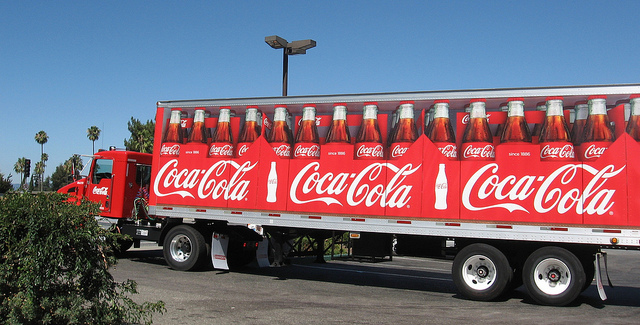Identify the text displayed in this image. CocaCola CocaCola Coca-Cola Coca Col CocaCola coca Coca Cola CocaCola Cola Caco Coca Cola coca CocaCola 